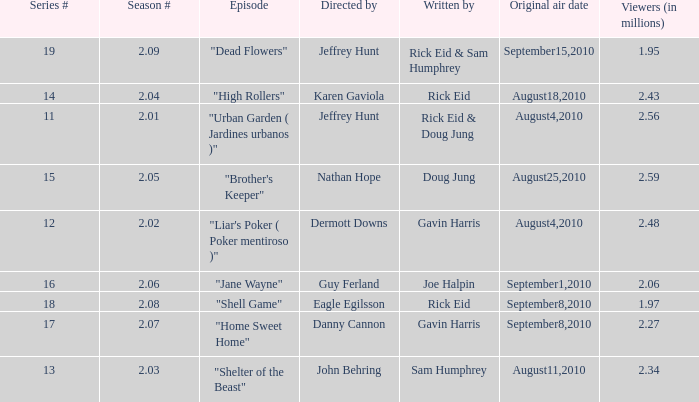What is the amount of viewers if the series number is 14? 2.43. 